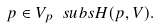<formula> <loc_0><loc_0><loc_500><loc_500>p \in V _ { p } \ s u b s H ( p , V ) .</formula> 